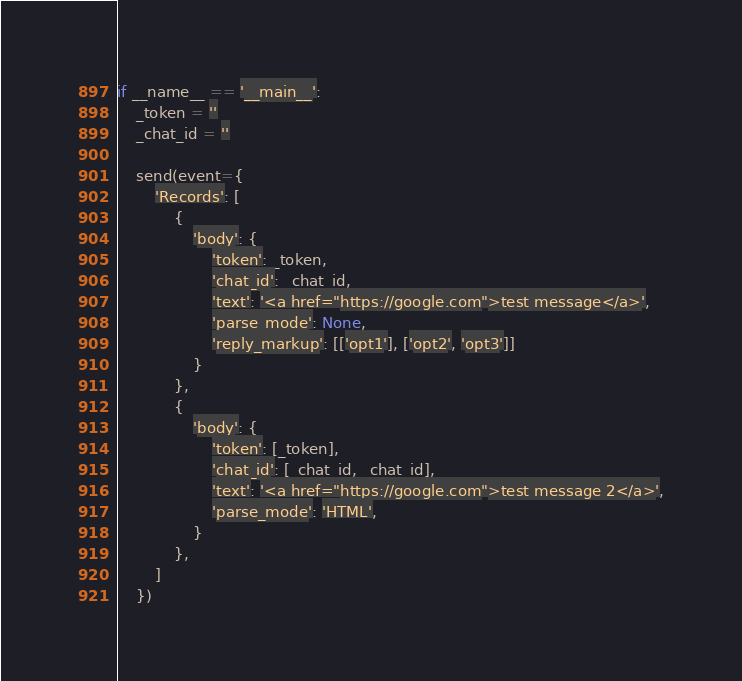<code> <loc_0><loc_0><loc_500><loc_500><_Python_>if __name__ == '__main__':
    _token = ''
    _chat_id = ''

    send(event={
        'Records': [
            {
                'body': {
                    'token': _token,
                    'chat_id': _chat_id,
                    'text': '<a href="https://google.com">test message</a>',
                    'parse_mode': None,
                    'reply_markup': [['opt1'], ['opt2', 'opt3']]
                }
            },
            {
                'body': {
                    'token': [_token],
                    'chat_id': [_chat_id, _chat_id],
                    'text': '<a href="https://google.com">test message 2</a>',
                    'parse_mode': 'HTML',
                }
            },
        ]
    })
</code> 